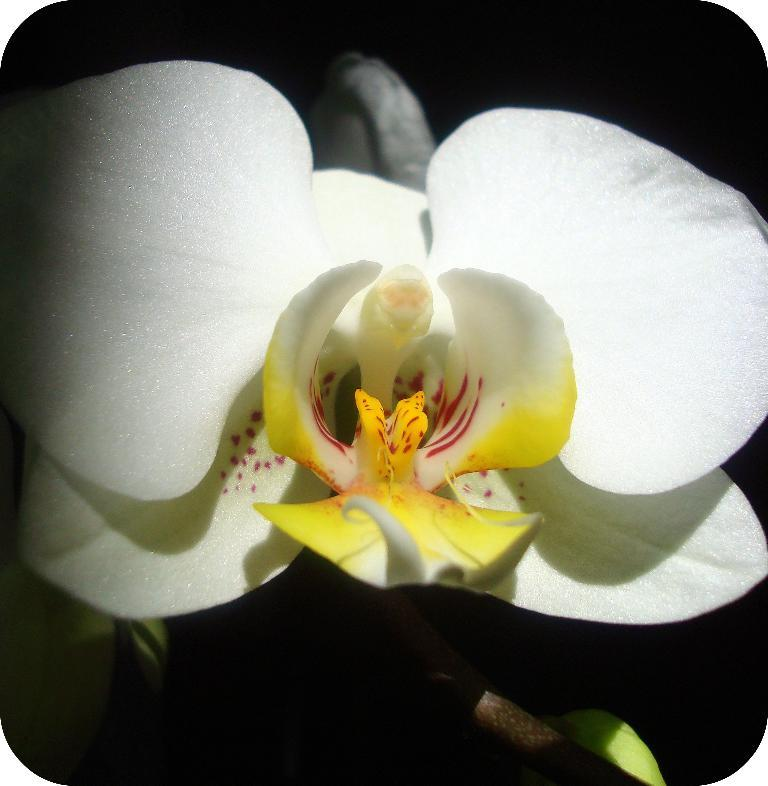What is the main subject of the image? There is a flower in the image. Can you describe the colors of the flower? The flower has white, yellow, and red colors. What color is the background of the image? The background of the image is black. How many chairs are visible in the image? There are no chairs present in the image; it features a flower with a black background. 